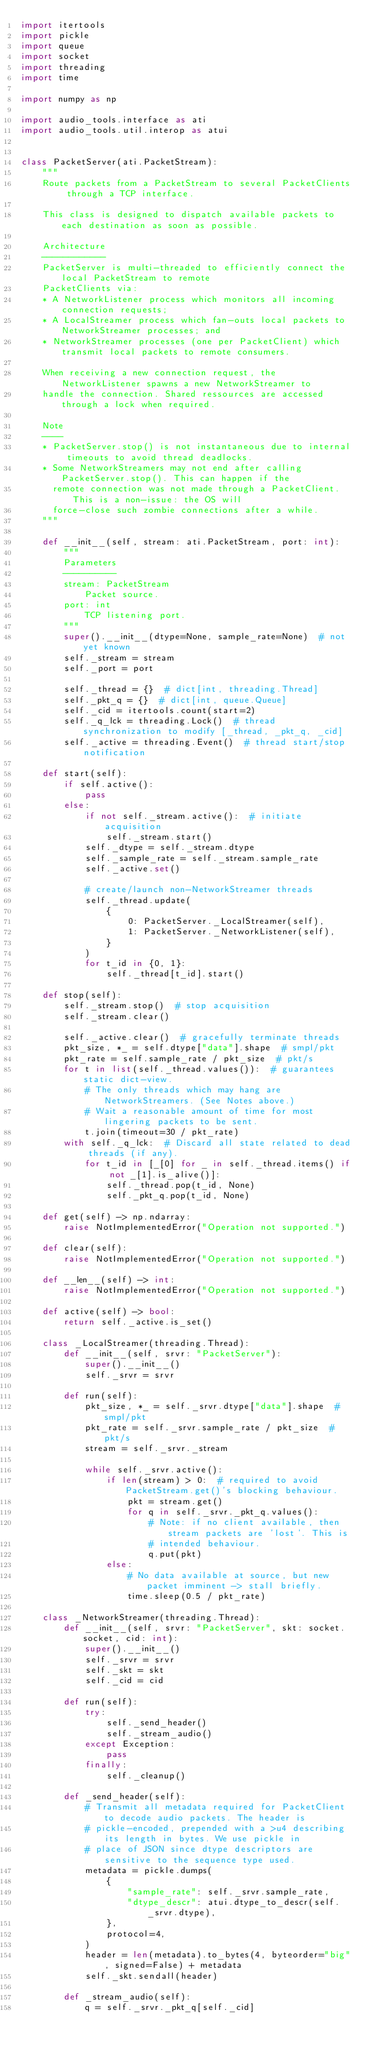Convert code to text. <code><loc_0><loc_0><loc_500><loc_500><_Python_>import itertools
import pickle
import queue
import socket
import threading
import time

import numpy as np

import audio_tools.interface as ati
import audio_tools.util.interop as atui


class PacketServer(ati.PacketStream):
    """
    Route packets from a PacketStream to several PacketClients through a TCP interface.

    This class is designed to dispatch available packets to each destination as soon as possible.

    Architecture
    ------------
    PacketServer is multi-threaded to efficiently connect the local PacketStream to remote
    PacketClients via:
    * A NetworkListener process which monitors all incoming connection requests;
    * A LocalStreamer process which fan-outs local packets to NetworkStreamer processes; and
    * NetworkStreamer processes (one per PacketClient) which transmit local packets to remote consumers.

    When receiving a new connection request, the NetworkListener spawns a new NetworkStreamer to
    handle the connection. Shared ressources are accessed through a lock when required.

    Note
    ----
    * PacketServer.stop() is not instantaneous due to internal timeouts to avoid thread deadlocks.
    * Some NetworkStreamers may not end after calling PacketServer.stop(). This can happen if the
      remote connection was not made through a PacketClient. This is a non-issue: the OS will
      force-close such zombie connections after a while.
    """

    def __init__(self, stream: ati.PacketStream, port: int):
        """
        Parameters
        ----------
        stream: PacketStream
            Packet source.
        port: int
            TCP listening port.
        """
        super().__init__(dtype=None, sample_rate=None)  # not yet known
        self._stream = stream
        self._port = port

        self._thread = {}  # dict[int, threading.Thread]
        self._pkt_q = {}  # dict[int, queue.Queue]
        self._cid = itertools.count(start=2)
        self._q_lck = threading.Lock()  # thread synchronization to modify [_thread, _pkt_q, _cid]
        self._active = threading.Event()  # thread start/stop notification

    def start(self):
        if self.active():
            pass
        else:
            if not self._stream.active():  # initiate acquisition
                self._stream.start()
            self._dtype = self._stream.dtype
            self._sample_rate = self._stream.sample_rate
            self._active.set()

            # create/launch non-NetworkStreamer threads
            self._thread.update(
                {
                    0: PacketServer._LocalStreamer(self),
                    1: PacketServer._NetworkListener(self),
                }
            )
            for t_id in {0, 1}:
                self._thread[t_id].start()

    def stop(self):
        self._stream.stop()  # stop acquisition
        self._stream.clear()

        self._active.clear()  # gracefully terminate threads
        pkt_size, *_ = self.dtype["data"].shape  # smpl/pkt
        pkt_rate = self.sample_rate / pkt_size  # pkt/s
        for t in list(self._thread.values()):  # guarantees static dict-view.
            # The only threads which may hang are NetworkStreamers. (See Notes above.)
            # Wait a reasonable amount of time for most lingering packets to be sent.
            t.join(timeout=30 / pkt_rate)
        with self._q_lck:  # Discard all state related to dead threads (if any).
            for t_id in [_[0] for _ in self._thread.items() if not _[1].is_alive()]:
                self._thread.pop(t_id, None)
                self._pkt_q.pop(t_id, None)

    def get(self) -> np.ndarray:
        raise NotImplementedError("Operation not supported.")

    def clear(self):
        raise NotImplementedError("Operation not supported.")

    def __len__(self) -> int:
        raise NotImplementedError("Operation not supported.")

    def active(self) -> bool:
        return self._active.is_set()

    class _LocalStreamer(threading.Thread):
        def __init__(self, srvr: "PacketServer"):
            super().__init__()
            self._srvr = srvr

        def run(self):
            pkt_size, *_ = self._srvr.dtype["data"].shape  # smpl/pkt
            pkt_rate = self._srvr.sample_rate / pkt_size  # pkt/s
            stream = self._srvr._stream

            while self._srvr.active():
                if len(stream) > 0:  # required to avoid PacketStream.get()'s blocking behaviour.
                    pkt = stream.get()
                    for q in self._srvr._pkt_q.values():
                        # Note: if no client available, then stream packets are 'lost'. This is
                        # intended behaviour.
                        q.put(pkt)
                else:
                    # No data available at source, but new packet imminent -> stall briefly.
                    time.sleep(0.5 / pkt_rate)

    class _NetworkStreamer(threading.Thread):
        def __init__(self, srvr: "PacketServer", skt: socket.socket, cid: int):
            super().__init__()
            self._srvr = srvr
            self._skt = skt
            self._cid = cid

        def run(self):
            try:
                self._send_header()
                self._stream_audio()
            except Exception:
                pass
            finally:
                self._cleanup()

        def _send_header(self):
            # Transmit all metadata required for PacketClient to decode audio packets. The header is
            # pickle-encoded, prepended with a >u4 describing its length in bytes. We use pickle in
            # place of JSON since dtype descriptors are sensitive to the sequence type used.
            metadata = pickle.dumps(
                {
                    "sample_rate": self._srvr.sample_rate,
                    "dtype_descr": atui.dtype_to_descr(self._srvr.dtype),
                },
                protocol=4,
            )
            header = len(metadata).to_bytes(4, byteorder="big", signed=False) + metadata
            self._skt.sendall(header)

        def _stream_audio(self):
            q = self._srvr._pkt_q[self._cid]</code> 